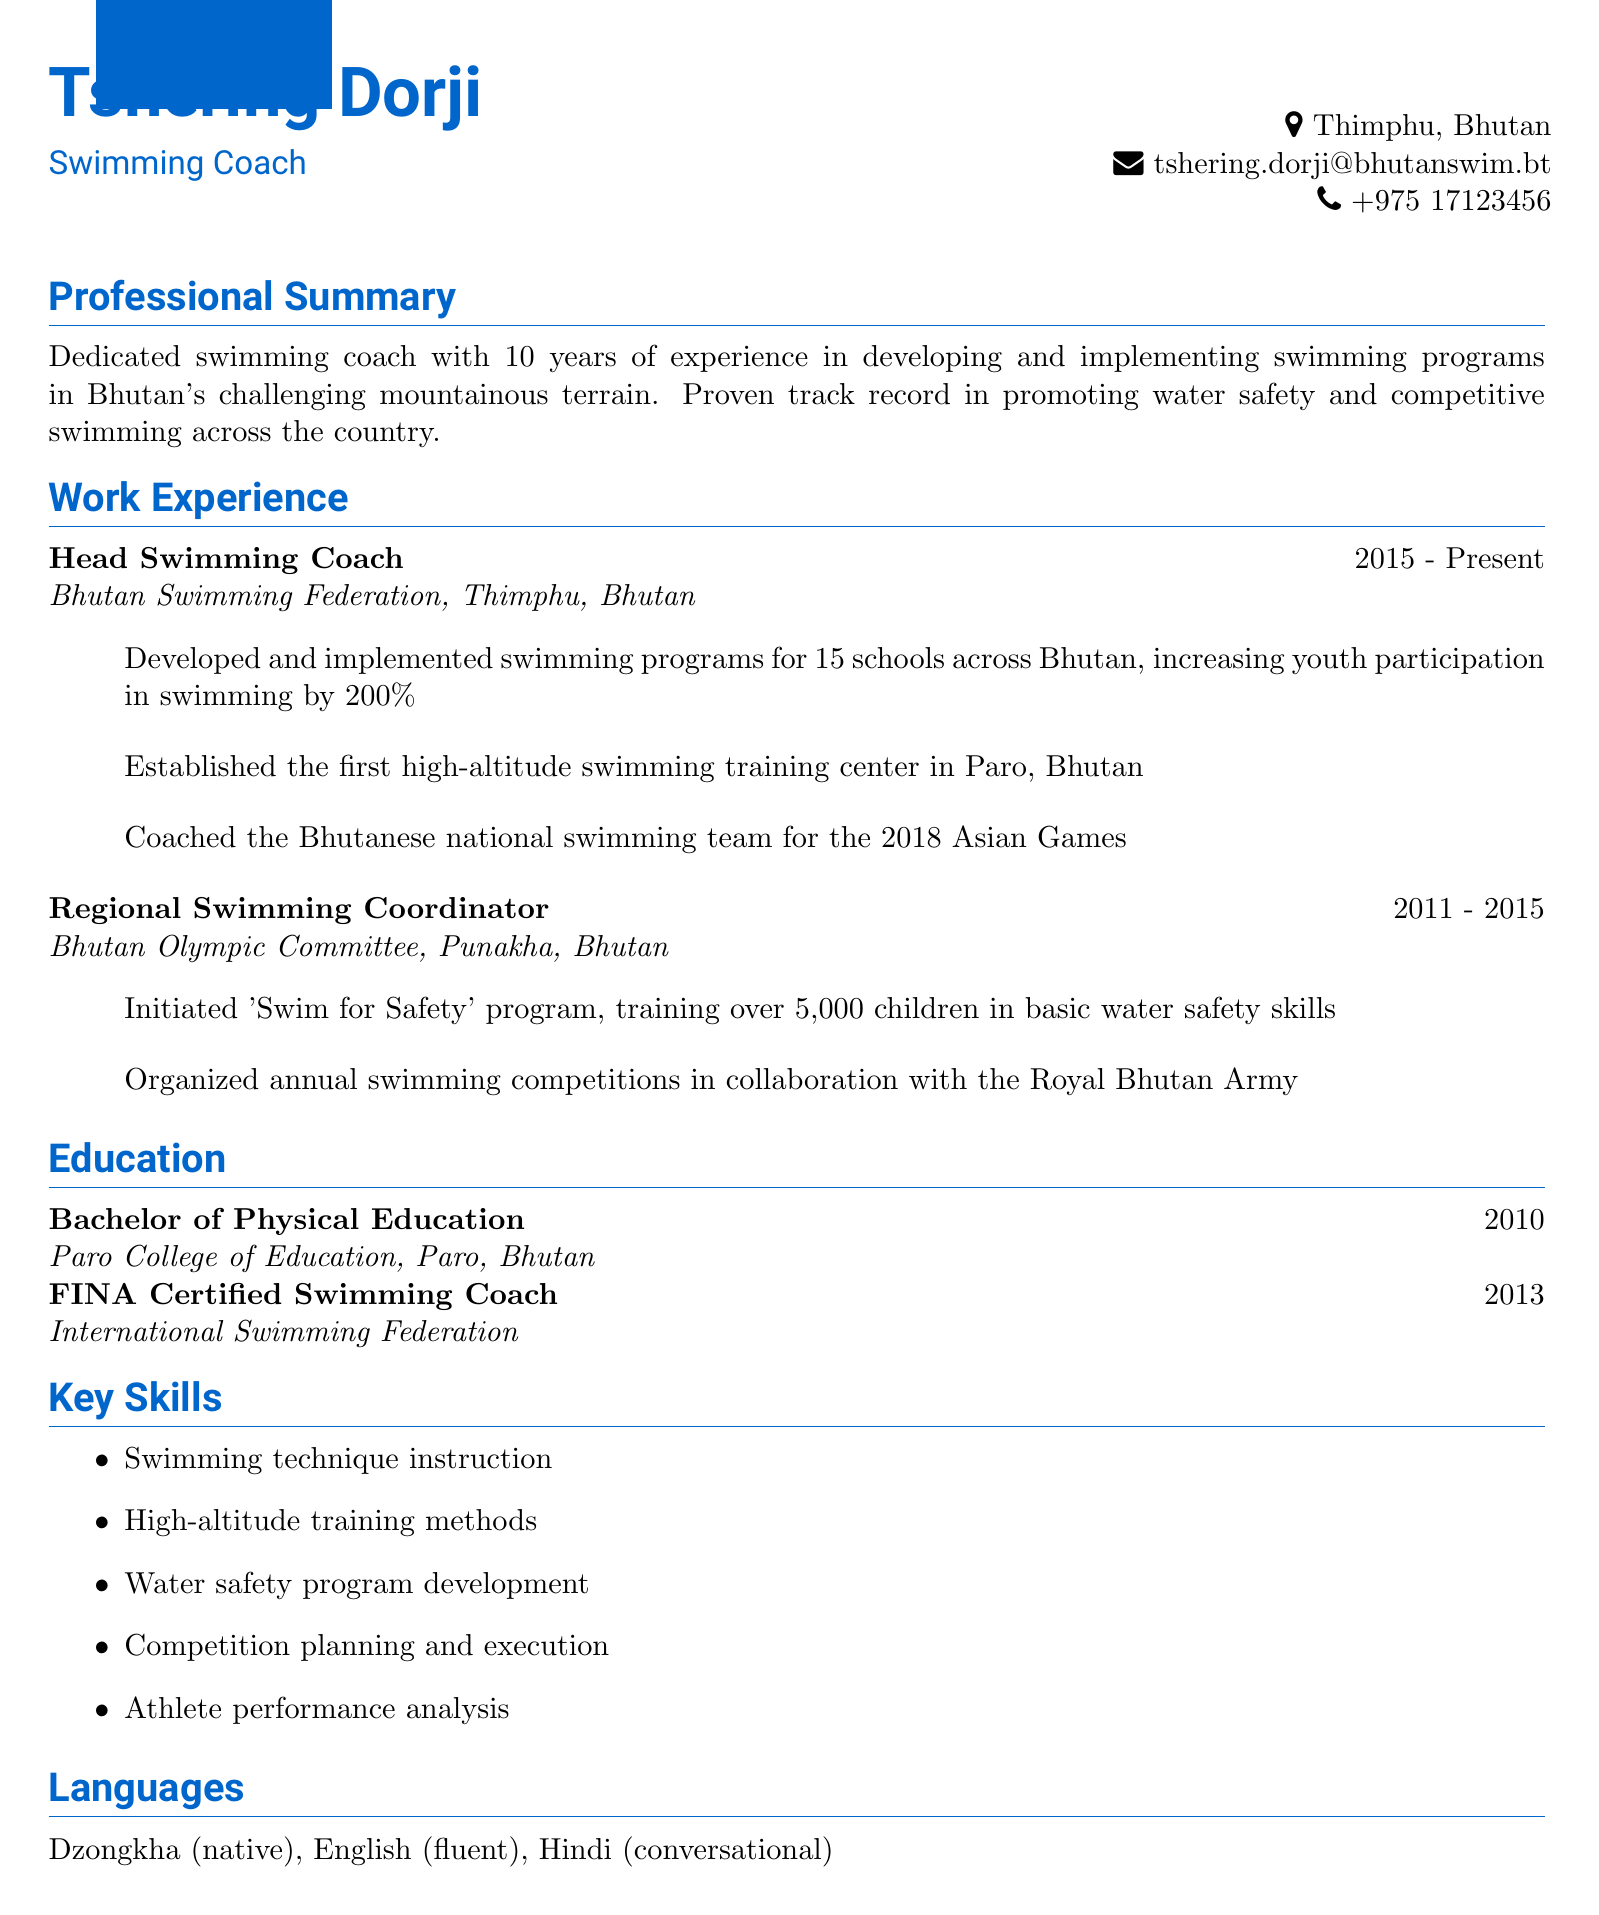What is the coach's name? The coach's name is stated at the top of the document as Tshering Dorji.
Answer: Tshering Dorji What is the location of the head swimming coach position? The head swimming coach position is based at the Bhutan Swimming Federation in Thimphu, Bhutan.
Answer: Thimphu, Bhutan How many years of experience does Tshering Dorji have? The document mentions that Tshering Dorji has 10 years of experience as a swimming coach.
Answer: 10 years What program did Tshering Dorji initiate that trained over 5,000 children? The document refers to the program initiated by Tshering Dorji as the 'Swim for Safety' program.
Answer: Swim for Safety In what year did Tshering Dorji graduate with a Bachelor of Physical Education? The graduation year for the Bachelor of Physical Education is listed as 2010.
Answer: 2010 How much did youth participation increase in swimming programs developed for schools? The document states that youth participation increased by 200%.
Answer: 200% Which certification was obtained in 2013? The certification obtained in 2013 is identified as being a FINA Certified Swimming Coach.
Answer: FINA Certified Swimming Coach What skills related to athlete performance does Tshering Dorji possess? The document lists athlete performance analysis as one of the key skills.
Answer: Athlete performance analysis 